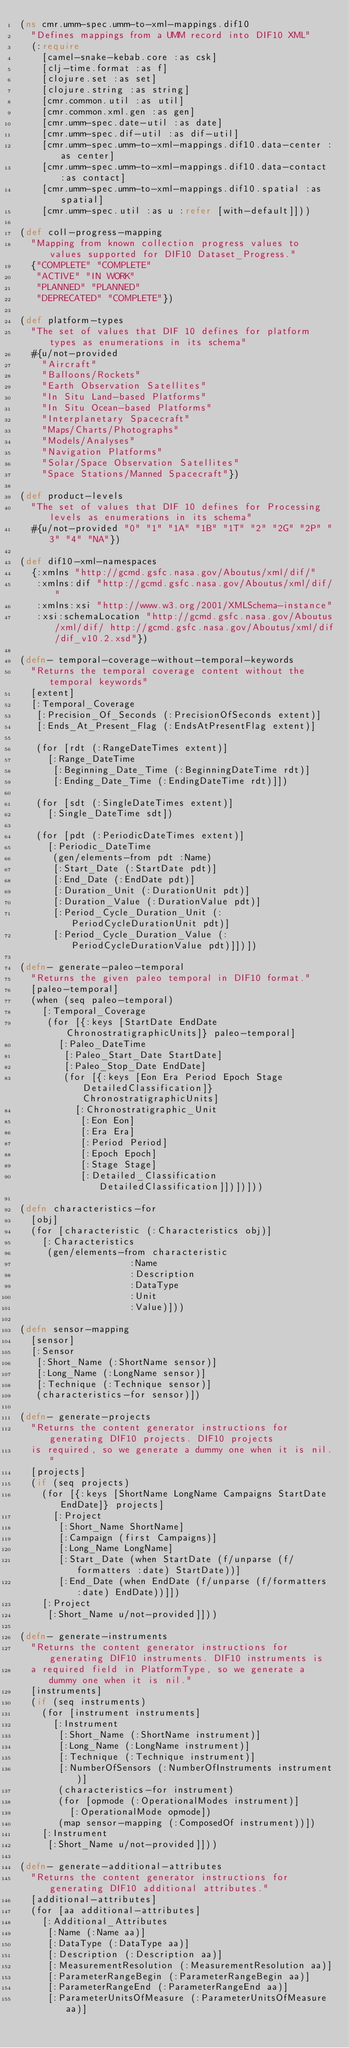<code> <loc_0><loc_0><loc_500><loc_500><_Clojure_>(ns cmr.umm-spec.umm-to-xml-mappings.dif10
  "Defines mappings from a UMM record into DIF10 XML"
  (:require
    [camel-snake-kebab.core :as csk]
    [clj-time.format :as f]
    [clojure.set :as set]
    [clojure.string :as string]
    [cmr.common.util :as util]
    [cmr.common.xml.gen :as gen]
    [cmr.umm-spec.date-util :as date]
    [cmr.umm-spec.dif-util :as dif-util]
    [cmr.umm-spec.umm-to-xml-mappings.dif10.data-center :as center]
    [cmr.umm-spec.umm-to-xml-mappings.dif10.data-contact :as contact]
    [cmr.umm-spec.umm-to-xml-mappings.dif10.spatial :as spatial]
    [cmr.umm-spec.util :as u :refer [with-default]]))

(def coll-progress-mapping
  "Mapping from known collection progress values to values supported for DIF10 Dataset_Progress."
  {"COMPLETE" "COMPLETE"
   "ACTIVE" "IN WORK"
   "PLANNED" "PLANNED"
   "DEPRECATED" "COMPLETE"})

(def platform-types
  "The set of values that DIF 10 defines for platform types as enumerations in its schema"
  #{u/not-provided
    "Aircraft"
    "Balloons/Rockets"
    "Earth Observation Satellites"
    "In Situ Land-based Platforms"
    "In Situ Ocean-based Platforms"
    "Interplanetary Spacecraft"
    "Maps/Charts/Photographs"
    "Models/Analyses"
    "Navigation Platforms"
    "Solar/Space Observation Satellites"
    "Space Stations/Manned Spacecraft"})

(def product-levels
  "The set of values that DIF 10 defines for Processing levels as enumerations in its schema"
  #{u/not-provided "0" "1" "1A" "1B" "1T" "2" "2G" "2P" "3" "4" "NA"})

(def dif10-xml-namespaces
  {:xmlns "http://gcmd.gsfc.nasa.gov/Aboutus/xml/dif/"
   :xmlns:dif "http://gcmd.gsfc.nasa.gov/Aboutus/xml/dif/"
   :xmlns:xsi "http://www.w3.org/2001/XMLSchema-instance"
   :xsi:schemaLocation "http://gcmd.gsfc.nasa.gov/Aboutus/xml/dif/ http://gcmd.gsfc.nasa.gov/Aboutus/xml/dif/dif_v10.2.xsd"})

(defn- temporal-coverage-without-temporal-keywords
  "Returns the temporal coverage content without the temporal keywords"
  [extent]
  [:Temporal_Coverage
   [:Precision_Of_Seconds (:PrecisionOfSeconds extent)]
   [:Ends_At_Present_Flag (:EndsAtPresentFlag extent)]

   (for [rdt (:RangeDateTimes extent)]
     [:Range_DateTime
      [:Beginning_Date_Time (:BeginningDateTime rdt)]
      [:Ending_Date_Time (:EndingDateTime rdt)]])

   (for [sdt (:SingleDateTimes extent)]
     [:Single_DateTime sdt])

   (for [pdt (:PeriodicDateTimes extent)]
     [:Periodic_DateTime
      (gen/elements-from pdt :Name)
      [:Start_Date (:StartDate pdt)]
      [:End_Date (:EndDate pdt)]
      [:Duration_Unit (:DurationUnit pdt)]
      [:Duration_Value (:DurationValue pdt)]
      [:Period_Cycle_Duration_Unit (:PeriodCycleDurationUnit pdt)]
      [:Period_Cycle_Duration_Value (:PeriodCycleDurationValue pdt)]])])

(defn- generate-paleo-temporal
  "Returns the given paleo temporal in DIF10 format."
  [paleo-temporal]
  (when (seq paleo-temporal)
    [:Temporal_Coverage
     (for [{:keys [StartDate EndDate ChronostratigraphicUnits]} paleo-temporal]
       [:Paleo_DateTime
        [:Paleo_Start_Date StartDate]
        [:Paleo_Stop_Date EndDate]
        (for [{:keys [Eon Era Period Epoch Stage DetailedClassification]} ChronostratigraphicUnits]
          [:Chronostratigraphic_Unit
           [:Eon Eon]
           [:Era Era]
           [:Period Period]
           [:Epoch Epoch]
           [:Stage Stage]
           [:Detailed_Classification DetailedClassification]])])]))

(defn characteristics-for
  [obj]
  (for [characteristic (:Characteristics obj)]
    [:Characteristics
     (gen/elements-from characteristic
                    :Name
                    :Description
                    :DataType
                    :Unit
                    :Value)]))

(defn sensor-mapping
  [sensor]
  [:Sensor
   [:Short_Name (:ShortName sensor)]
   [:Long_Name (:LongName sensor)]
   [:Technique (:Technique sensor)]
   (characteristics-for sensor)])

(defn- generate-projects
  "Returns the content generator instructions for generating DIF10 projects. DIF10 projects
  is required, so we generate a dummy one when it is nil."
  [projects]
  (if (seq projects)
    (for [{:keys [ShortName LongName Campaigns StartDate EndDate]} projects]
      [:Project
       [:Short_Name ShortName]
       [:Campaign (first Campaigns)]
       [:Long_Name LongName]
       [:Start_Date (when StartDate (f/unparse (f/formatters :date) StartDate))]
       [:End_Date (when EndDate (f/unparse (f/formatters :date) EndDate))]])
    [:Project
     [:Short_Name u/not-provided]]))

(defn- generate-instruments
  "Returns the content generator instructions for generating DIF10 instruments. DIF10 instruments is
  a required field in PlatformType, so we generate a dummy one when it is nil."
  [instruments]
  (if (seq instruments)
    (for [instrument instruments]
      [:Instrument
       [:Short_Name (:ShortName instrument)]
       [:Long_Name (:LongName instrument)]
       [:Technique (:Technique instrument)]
       [:NumberOfSensors (:NumberOfInstruments instrument)]
       (characteristics-for instrument)
       (for [opmode (:OperationalModes instrument)]
         [:OperationalMode opmode])
       (map sensor-mapping (:ComposedOf instrument))])
    [:Instrument
     [:Short_Name u/not-provided]]))

(defn- generate-additional-attributes
  "Returns the content generator instructions for generating DIF10 additional attributes."
  [additional-attributes]
  (for [aa additional-attributes]
    [:Additional_Attributes
     [:Name (:Name aa)]
     [:DataType (:DataType aa)]
     [:Description (:Description aa)]
     [:MeasurementResolution (:MeasurementResolution aa)]
     [:ParameterRangeBegin (:ParameterRangeBegin aa)]
     [:ParameterRangeEnd (:ParameterRangeEnd aa)]
     [:ParameterUnitsOfMeasure (:ParameterUnitsOfMeasure aa)]</code> 